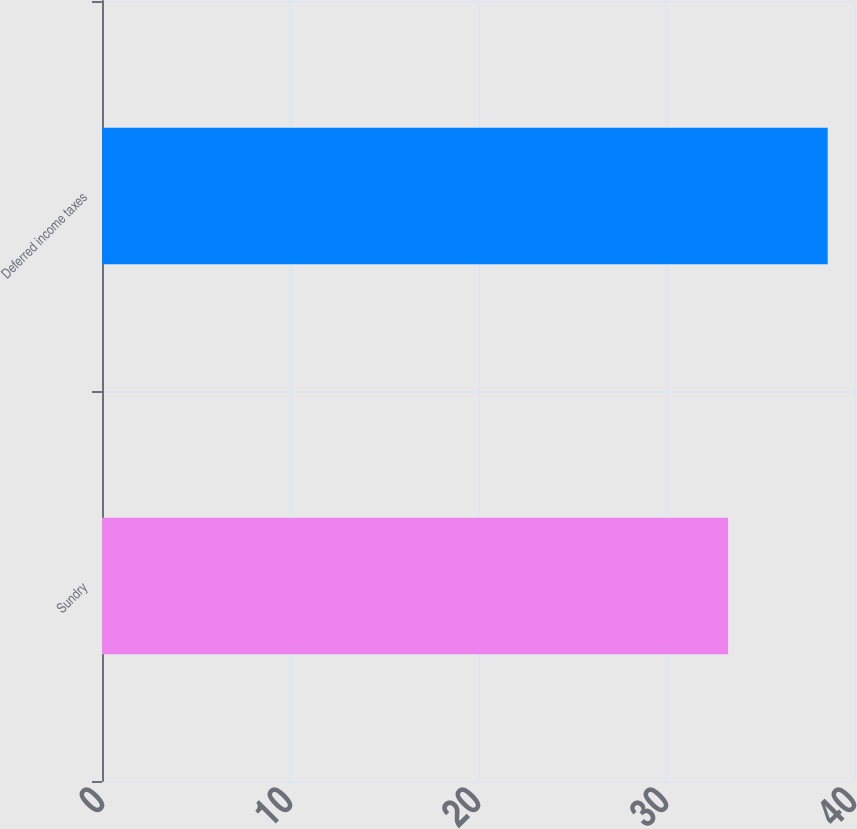Convert chart to OTSL. <chart><loc_0><loc_0><loc_500><loc_500><bar_chart><fcel>Sundry<fcel>Deferred income taxes<nl><fcel>33.3<fcel>38.6<nl></chart> 